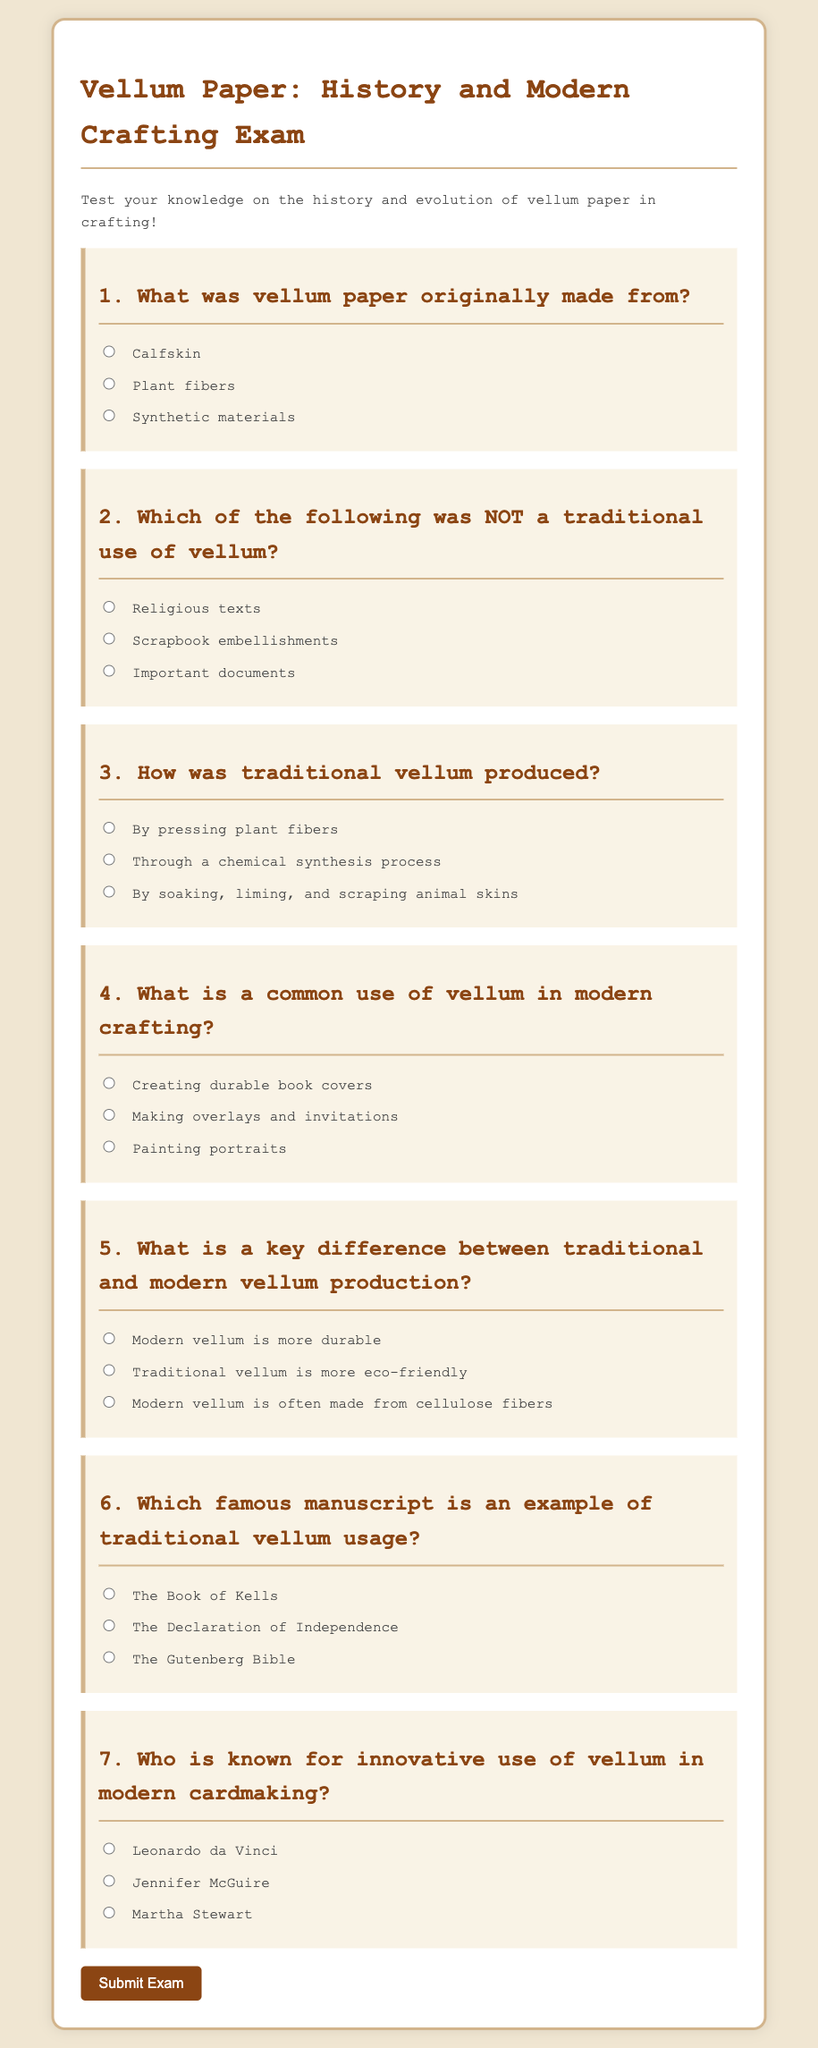What was vellum paper originally made from? The question refers to the information provided in question 1 of the document, which asks specifically about the material used to create vellum paper historically.
Answer: Calfskin Which of the following was NOT a traditional use of vellum? This question relates to question 2 in the document, where it distinguishes between historical uses of vellum and modern applications.
Answer: Scrapbook embellishments How was traditional vellum produced? This inquiry is based on question 3, which describes the traditional production methods of vellum as outlined in the document.
Answer: By soaking, liming, and scraping animal skins What is a common use of vellum in modern crafting? This question is linked to question 4, highlighting the contemporary applications of vellum in crafting practices mentioned in the document.
Answer: Making overlays and invitations Which famous manuscript is an example of traditional vellum usage? Question 6 in the document provides options for significant manuscripts that utilized vellum, requiring the identification of one.
Answer: The Book of Kells 